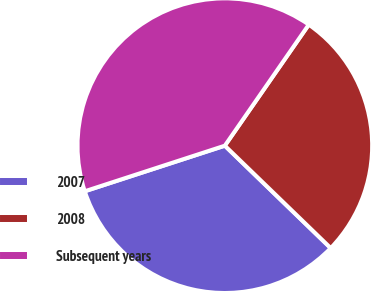<chart> <loc_0><loc_0><loc_500><loc_500><pie_chart><fcel>2007<fcel>2008<fcel>Subsequent years<nl><fcel>32.76%<fcel>27.59%<fcel>39.66%<nl></chart> 